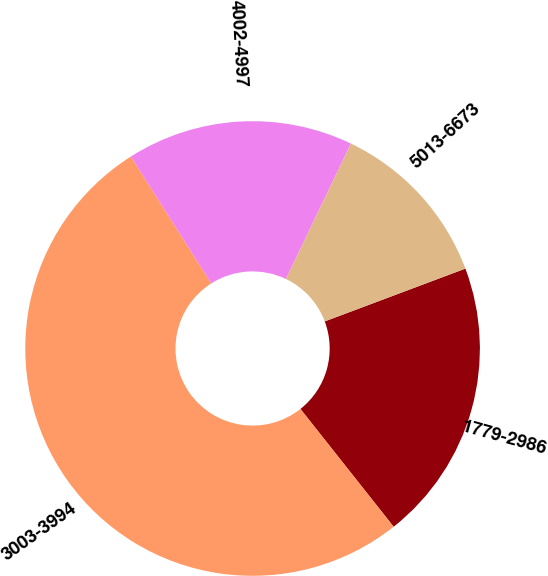Convert chart to OTSL. <chart><loc_0><loc_0><loc_500><loc_500><pie_chart><fcel>1779-2986<fcel>3003-3994<fcel>4002-4997<fcel>5013-6673<nl><fcel>20.06%<fcel>51.66%<fcel>16.11%<fcel>12.16%<nl></chart> 